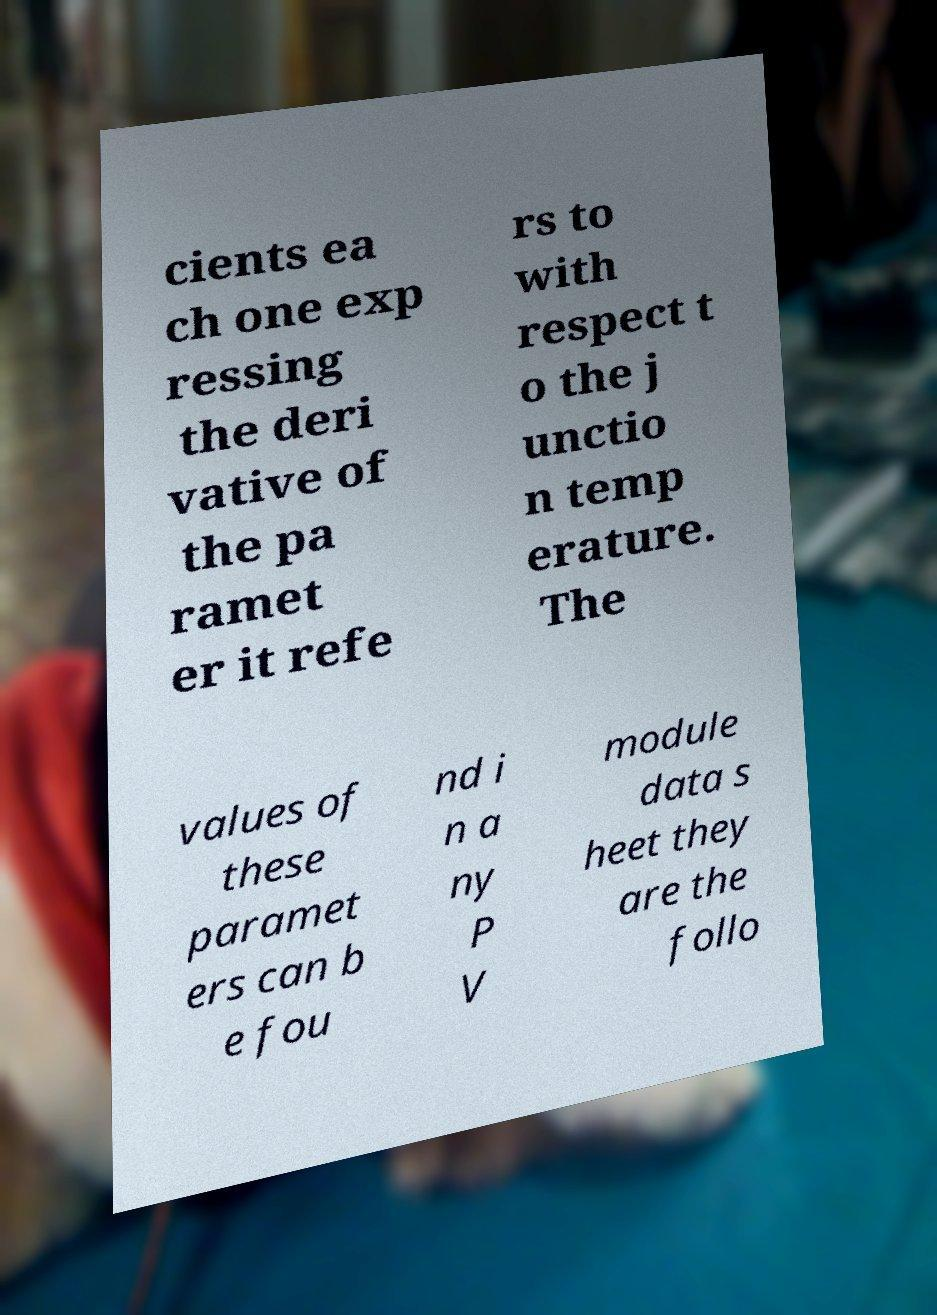Can you accurately transcribe the text from the provided image for me? cients ea ch one exp ressing the deri vative of the pa ramet er it refe rs to with respect t o the j unctio n temp erature. The values of these paramet ers can b e fou nd i n a ny P V module data s heet they are the follo 